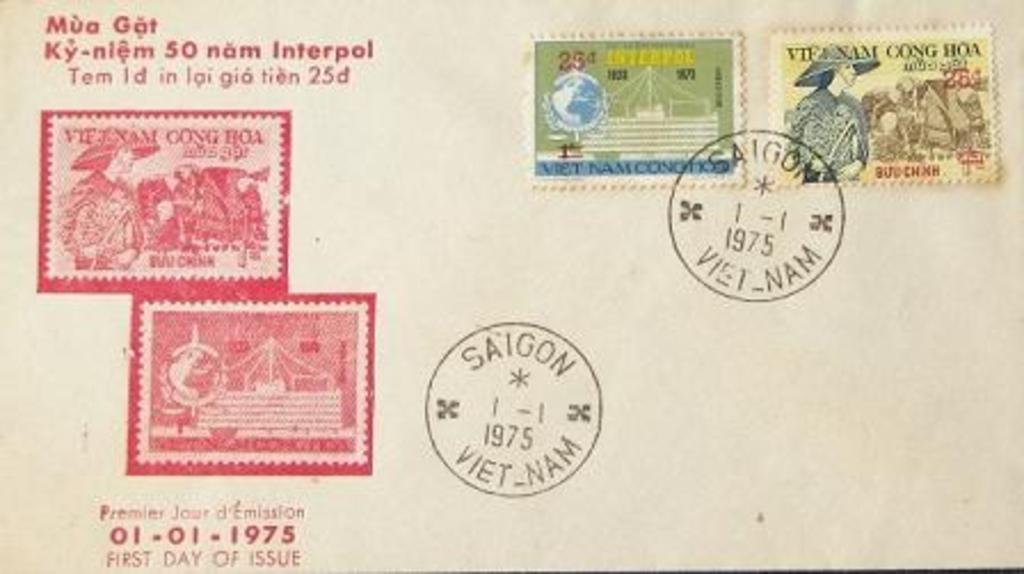What is the year of the stamp?
Offer a very short reply. 1975. What country is the round postal stamp from?
Your answer should be compact. Vietnam. 